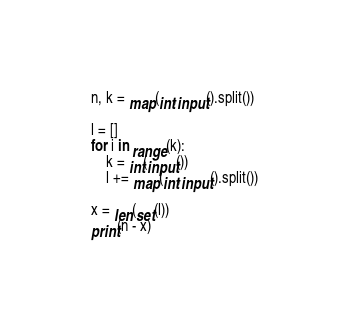<code> <loc_0><loc_0><loc_500><loc_500><_Python_>
n, k = map(int,input().split())

l = []
for i in range(k):
    k = int(input())
    l += map(int,input().split())

x = len(set(l))
print(n - x)



</code> 